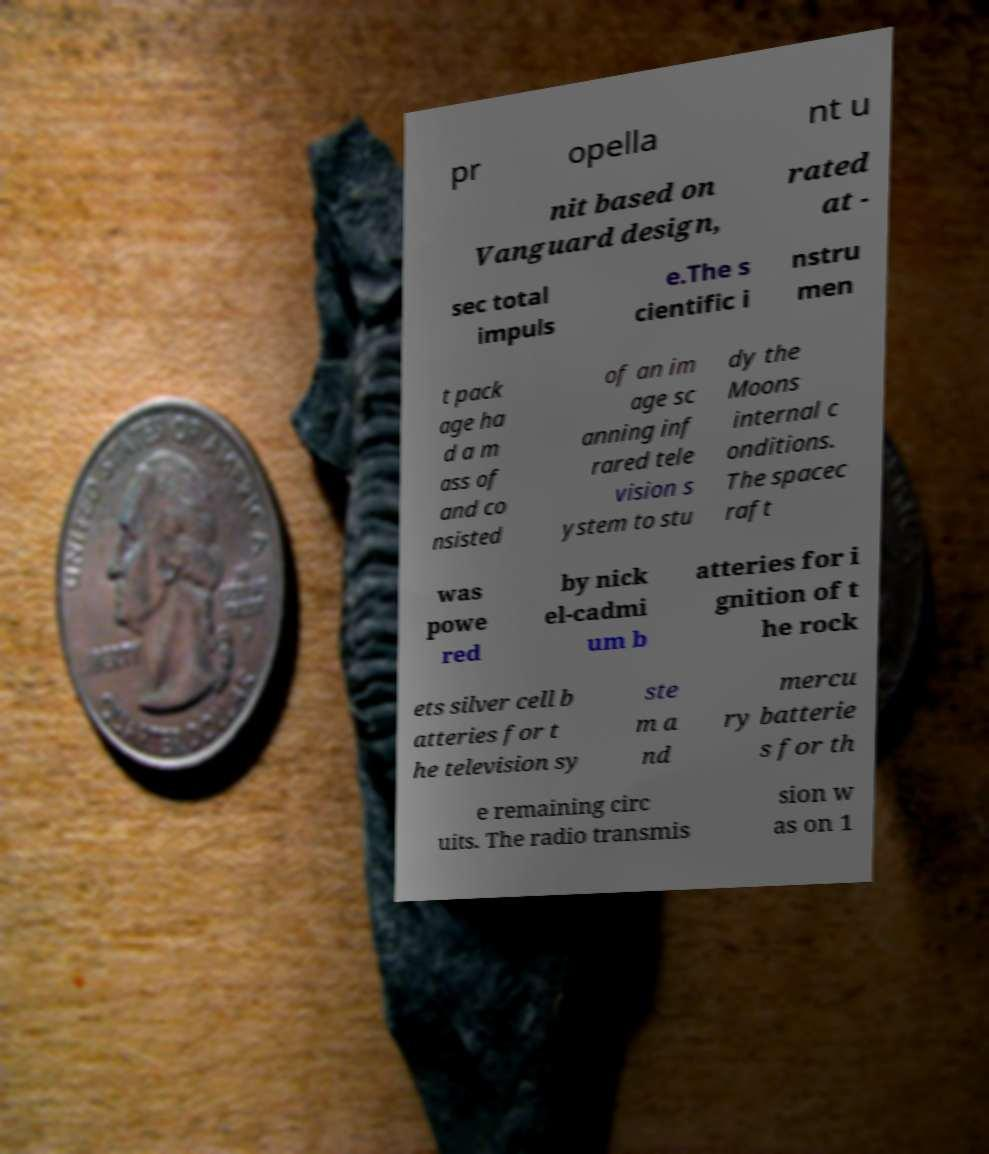Please identify and transcribe the text found in this image. pr opella nt u nit based on Vanguard design, rated at - sec total impuls e.The s cientific i nstru men t pack age ha d a m ass of and co nsisted of an im age sc anning inf rared tele vision s ystem to stu dy the Moons internal c onditions. The spacec raft was powe red by nick el-cadmi um b atteries for i gnition of t he rock ets silver cell b atteries for t he television sy ste m a nd mercu ry batterie s for th e remaining circ uits. The radio transmis sion w as on 1 